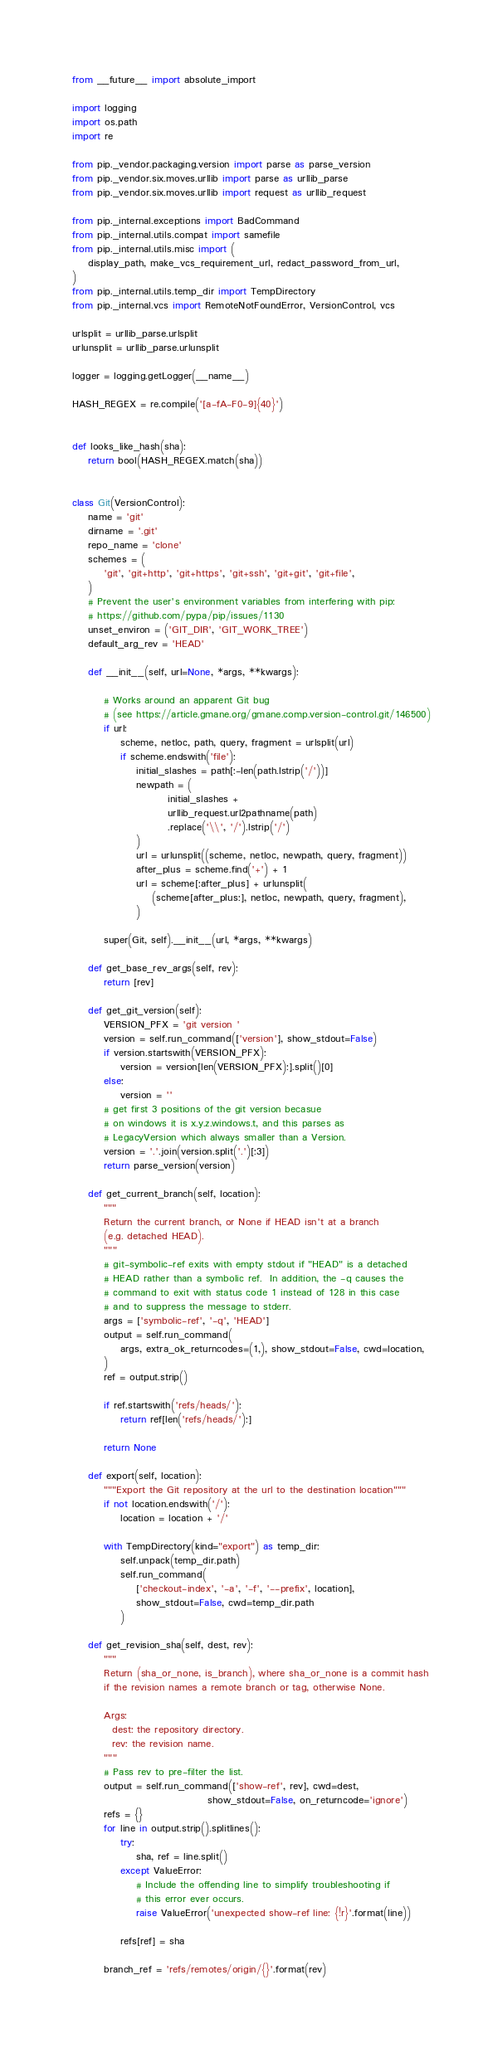Convert code to text. <code><loc_0><loc_0><loc_500><loc_500><_Python_>from __future__ import absolute_import

import logging
import os.path
import re

from pip._vendor.packaging.version import parse as parse_version
from pip._vendor.six.moves.urllib import parse as urllib_parse
from pip._vendor.six.moves.urllib import request as urllib_request

from pip._internal.exceptions import BadCommand
from pip._internal.utils.compat import samefile
from pip._internal.utils.misc import (
    display_path, make_vcs_requirement_url, redact_password_from_url,
)
from pip._internal.utils.temp_dir import TempDirectory
from pip._internal.vcs import RemoteNotFoundError, VersionControl, vcs

urlsplit = urllib_parse.urlsplit
urlunsplit = urllib_parse.urlunsplit

logger = logging.getLogger(__name__)

HASH_REGEX = re.compile('[a-fA-F0-9]{40}')


def looks_like_hash(sha):
    return bool(HASH_REGEX.match(sha))


class Git(VersionControl):
    name = 'git'
    dirname = '.git'
    repo_name = 'clone'
    schemes = (
        'git', 'git+http', 'git+https', 'git+ssh', 'git+git', 'git+file',
    )
    # Prevent the user's environment variables from interfering with pip:
    # https://github.com/pypa/pip/issues/1130
    unset_environ = ('GIT_DIR', 'GIT_WORK_TREE')
    default_arg_rev = 'HEAD'

    def __init__(self, url=None, *args, **kwargs):

        # Works around an apparent Git bug
        # (see https://article.gmane.org/gmane.comp.version-control.git/146500)
        if url:
            scheme, netloc, path, query, fragment = urlsplit(url)
            if scheme.endswith('file'):
                initial_slashes = path[:-len(path.lstrip('/'))]
                newpath = (
                        initial_slashes +
                        urllib_request.url2pathname(path)
                        .replace('\\', '/').lstrip('/')
                )
                url = urlunsplit((scheme, netloc, newpath, query, fragment))
                after_plus = scheme.find('+') + 1
                url = scheme[:after_plus] + urlunsplit(
                    (scheme[after_plus:], netloc, newpath, query, fragment),
                )

        super(Git, self).__init__(url, *args, **kwargs)

    def get_base_rev_args(self, rev):
        return [rev]

    def get_git_version(self):
        VERSION_PFX = 'git version '
        version = self.run_command(['version'], show_stdout=False)
        if version.startswith(VERSION_PFX):
            version = version[len(VERSION_PFX):].split()[0]
        else:
            version = ''
        # get first 3 positions of the git version becasue
        # on windows it is x.y.z.windows.t, and this parses as
        # LegacyVersion which always smaller than a Version.
        version = '.'.join(version.split('.')[:3])
        return parse_version(version)

    def get_current_branch(self, location):
        """
        Return the current branch, or None if HEAD isn't at a branch
        (e.g. detached HEAD).
        """
        # git-symbolic-ref exits with empty stdout if "HEAD" is a detached
        # HEAD rather than a symbolic ref.  In addition, the -q causes the
        # command to exit with status code 1 instead of 128 in this case
        # and to suppress the message to stderr.
        args = ['symbolic-ref', '-q', 'HEAD']
        output = self.run_command(
            args, extra_ok_returncodes=(1,), show_stdout=False, cwd=location,
        )
        ref = output.strip()

        if ref.startswith('refs/heads/'):
            return ref[len('refs/heads/'):]

        return None

    def export(self, location):
        """Export the Git repository at the url to the destination location"""
        if not location.endswith('/'):
            location = location + '/'

        with TempDirectory(kind="export") as temp_dir:
            self.unpack(temp_dir.path)
            self.run_command(
                ['checkout-index', '-a', '-f', '--prefix', location],
                show_stdout=False, cwd=temp_dir.path
            )

    def get_revision_sha(self, dest, rev):
        """
        Return (sha_or_none, is_branch), where sha_or_none is a commit hash
        if the revision names a remote branch or tag, otherwise None.

        Args:
          dest: the repository directory.
          rev: the revision name.
        """
        # Pass rev to pre-filter the list.
        output = self.run_command(['show-ref', rev], cwd=dest,
                                  show_stdout=False, on_returncode='ignore')
        refs = {}
        for line in output.strip().splitlines():
            try:
                sha, ref = line.split()
            except ValueError:
                # Include the offending line to simplify troubleshooting if
                # this error ever occurs.
                raise ValueError('unexpected show-ref line: {!r}'.format(line))

            refs[ref] = sha

        branch_ref = 'refs/remotes/origin/{}'.format(rev)</code> 